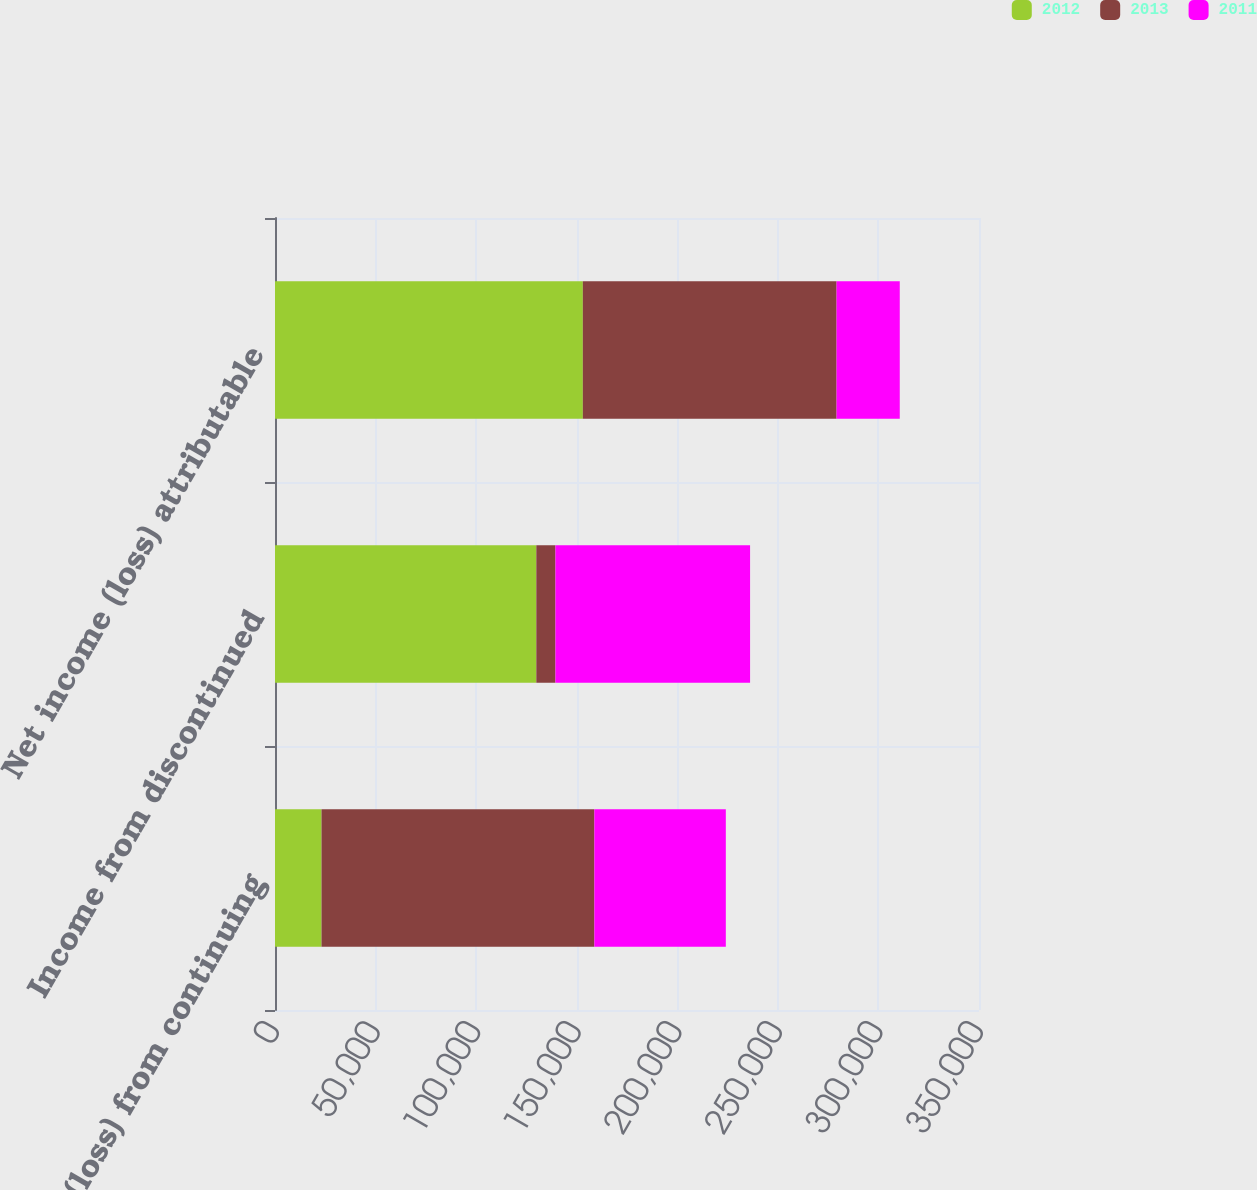<chart> <loc_0><loc_0><loc_500><loc_500><stacked_bar_chart><ecel><fcel>Income (loss) from continuing<fcel>Income from discontinued<fcel>Net income (loss) attributable<nl><fcel>2012<fcel>23126<fcel>129918<fcel>153044<nl><fcel>2013<fcel>135655<fcel>9510<fcel>126145<nl><fcel>2011<fcel>65345<fcel>96761<fcel>31416<nl></chart> 